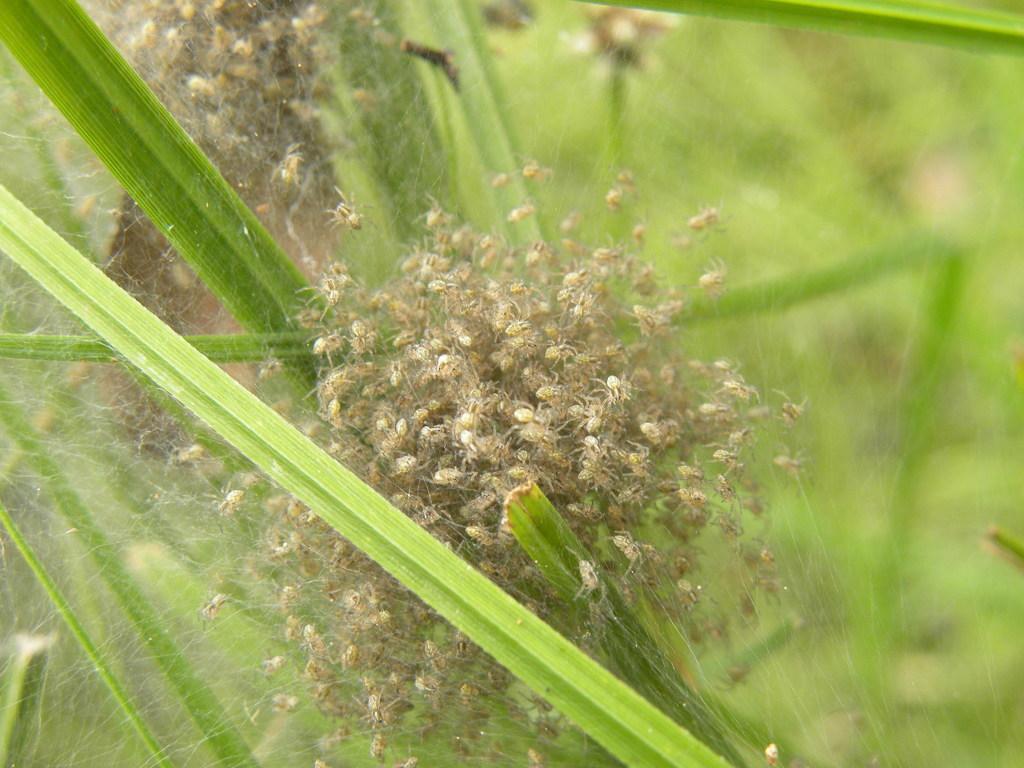Describe this image in one or two sentences. On this spider web there are spiders. Background it is in green color. 